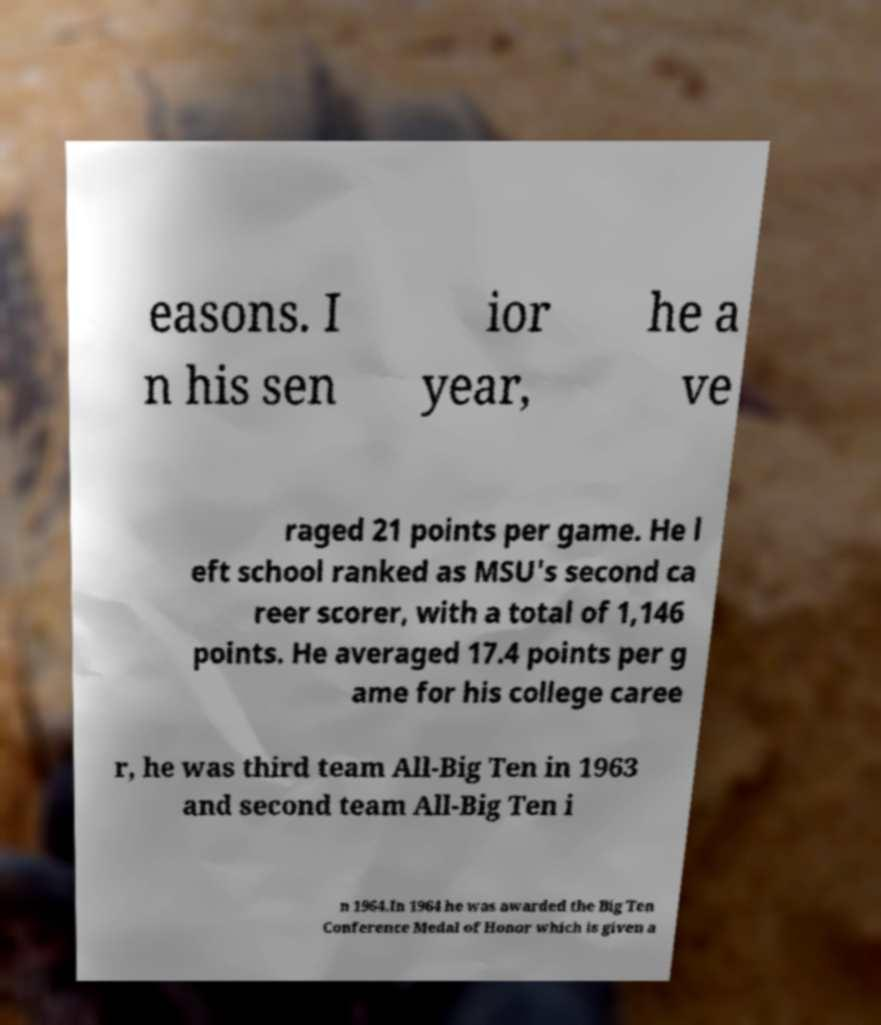Can you read and provide the text displayed in the image?This photo seems to have some interesting text. Can you extract and type it out for me? easons. I n his sen ior year, he a ve raged 21 points per game. He l eft school ranked as MSU's second ca reer scorer, with a total of 1,146 points. He averaged 17.4 points per g ame for his college caree r, he was third team All-Big Ten in 1963 and second team All-Big Ten i n 1964.In 1964 he was awarded the Big Ten Conference Medal of Honor which is given a 